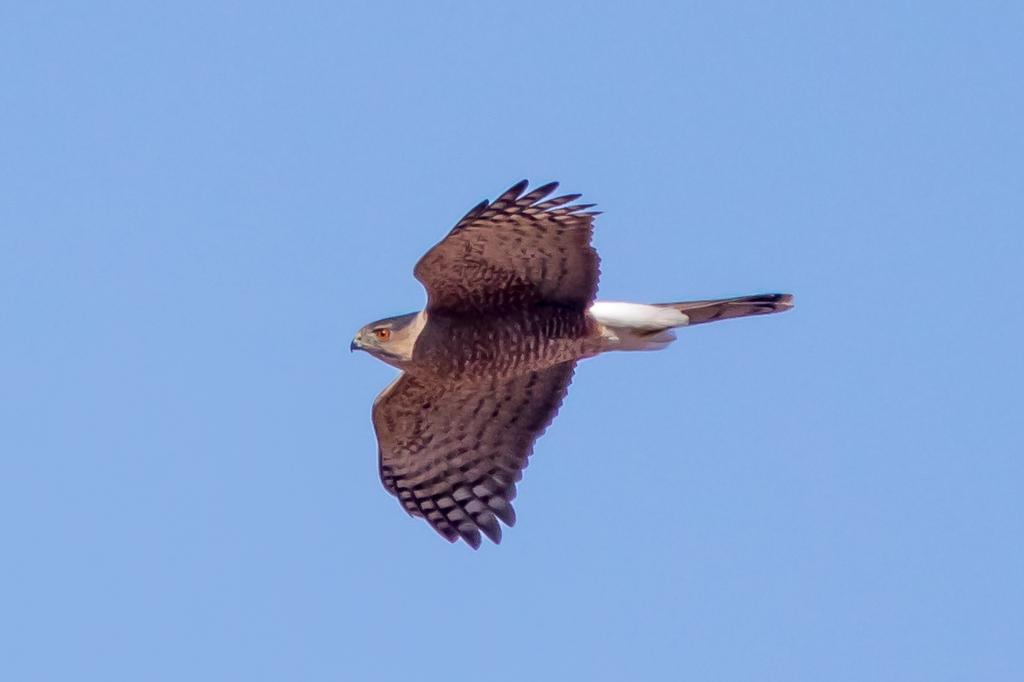What animal can be seen in the picture? There is an eagle in the picture. What is the eagle doing in the image? The eagle is flying in the air. What are the colors of the eagle? The eagle is white in color, with brown wings and tail. What is the color of the sky in the background? The sky in the background is blue in color. What does the caption below the picture say? There is no caption present in the image, so it cannot be read or described. 